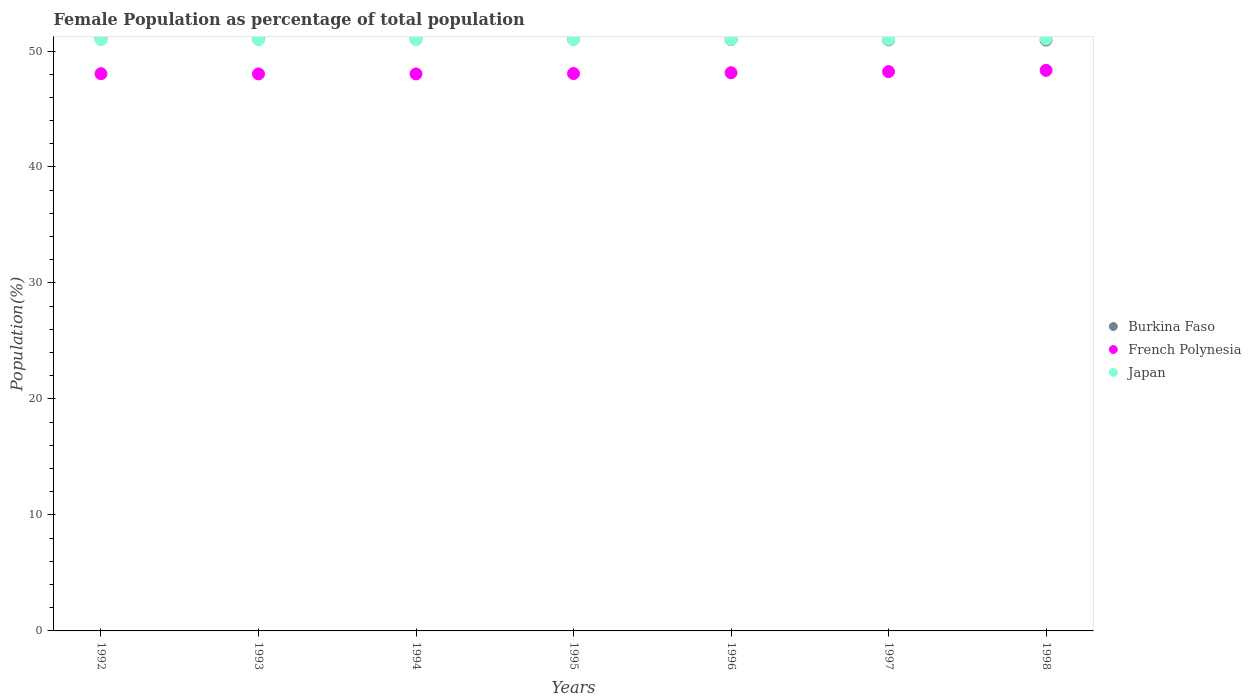What is the female population in in Japan in 1993?
Offer a very short reply. 50.98. Across all years, what is the maximum female population in in Burkina Faso?
Keep it short and to the point. 51.09. Across all years, what is the minimum female population in in Japan?
Your answer should be compact. 50.98. In which year was the female population in in French Polynesia minimum?
Give a very brief answer. 1994. What is the total female population in in French Polynesia in the graph?
Ensure brevity in your answer.  336.83. What is the difference between the female population in in French Polynesia in 1993 and that in 1998?
Give a very brief answer. -0.31. What is the difference between the female population in in French Polynesia in 1998 and the female population in in Burkina Faso in 1996?
Your response must be concise. -2.66. What is the average female population in in Japan per year?
Your answer should be very brief. 51. In the year 1998, what is the difference between the female population in in French Polynesia and female population in in Burkina Faso?
Keep it short and to the point. -2.61. What is the ratio of the female population in in Burkina Faso in 1992 to that in 1994?
Ensure brevity in your answer.  1. Is the female population in in French Polynesia in 1993 less than that in 1995?
Your answer should be very brief. Yes. What is the difference between the highest and the second highest female population in in Burkina Faso?
Your answer should be very brief. 0.03. What is the difference between the highest and the lowest female population in in Burkina Faso?
Ensure brevity in your answer.  0.15. In how many years, is the female population in in French Polynesia greater than the average female population in in French Polynesia taken over all years?
Keep it short and to the point. 3. Is it the case that in every year, the sum of the female population in in Burkina Faso and female population in in Japan  is greater than the female population in in French Polynesia?
Ensure brevity in your answer.  Yes. Is the female population in in Japan strictly greater than the female population in in French Polynesia over the years?
Keep it short and to the point. Yes. How many years are there in the graph?
Your response must be concise. 7. What is the difference between two consecutive major ticks on the Y-axis?
Keep it short and to the point. 10. Where does the legend appear in the graph?
Your response must be concise. Center right. How are the legend labels stacked?
Ensure brevity in your answer.  Vertical. What is the title of the graph?
Keep it short and to the point. Female Population as percentage of total population. What is the label or title of the X-axis?
Make the answer very short. Years. What is the label or title of the Y-axis?
Keep it short and to the point. Population(%). What is the Population(%) of Burkina Faso in 1992?
Your answer should be very brief. 51.09. What is the Population(%) in French Polynesia in 1992?
Keep it short and to the point. 48.05. What is the Population(%) in Japan in 1992?
Keep it short and to the point. 50.98. What is the Population(%) in Burkina Faso in 1993?
Offer a terse response. 51.07. What is the Population(%) of French Polynesia in 1993?
Provide a succinct answer. 48.03. What is the Population(%) in Japan in 1993?
Offer a very short reply. 50.98. What is the Population(%) in Burkina Faso in 1994?
Make the answer very short. 51.04. What is the Population(%) of French Polynesia in 1994?
Your answer should be compact. 48.02. What is the Population(%) in Japan in 1994?
Provide a short and direct response. 50.98. What is the Population(%) of Burkina Faso in 1995?
Your answer should be compact. 51.01. What is the Population(%) in French Polynesia in 1995?
Your response must be concise. 48.06. What is the Population(%) of Japan in 1995?
Provide a short and direct response. 50.99. What is the Population(%) in Burkina Faso in 1996?
Your answer should be very brief. 50.99. What is the Population(%) of French Polynesia in 1996?
Offer a very short reply. 48.13. What is the Population(%) in Japan in 1996?
Keep it short and to the point. 51. What is the Population(%) of Burkina Faso in 1997?
Your response must be concise. 50.97. What is the Population(%) in French Polynesia in 1997?
Offer a very short reply. 48.22. What is the Population(%) of Japan in 1997?
Give a very brief answer. 51.02. What is the Population(%) of Burkina Faso in 1998?
Ensure brevity in your answer.  50.94. What is the Population(%) in French Polynesia in 1998?
Provide a succinct answer. 48.33. What is the Population(%) in Japan in 1998?
Provide a short and direct response. 51.04. Across all years, what is the maximum Population(%) of Burkina Faso?
Ensure brevity in your answer.  51.09. Across all years, what is the maximum Population(%) in French Polynesia?
Give a very brief answer. 48.33. Across all years, what is the maximum Population(%) of Japan?
Give a very brief answer. 51.04. Across all years, what is the minimum Population(%) in Burkina Faso?
Provide a short and direct response. 50.94. Across all years, what is the minimum Population(%) of French Polynesia?
Provide a succinct answer. 48.02. Across all years, what is the minimum Population(%) of Japan?
Ensure brevity in your answer.  50.98. What is the total Population(%) in Burkina Faso in the graph?
Offer a very short reply. 357.11. What is the total Population(%) in French Polynesia in the graph?
Provide a succinct answer. 336.83. What is the total Population(%) of Japan in the graph?
Provide a succinct answer. 356.99. What is the difference between the Population(%) in Burkina Faso in 1992 and that in 1993?
Your answer should be very brief. 0.03. What is the difference between the Population(%) in French Polynesia in 1992 and that in 1993?
Give a very brief answer. 0.02. What is the difference between the Population(%) in Japan in 1992 and that in 1993?
Make the answer very short. -0. What is the difference between the Population(%) of Burkina Faso in 1992 and that in 1994?
Give a very brief answer. 0.05. What is the difference between the Population(%) of French Polynesia in 1992 and that in 1994?
Ensure brevity in your answer.  0.02. What is the difference between the Population(%) of Japan in 1992 and that in 1994?
Your answer should be very brief. -0. What is the difference between the Population(%) of Burkina Faso in 1992 and that in 1995?
Your answer should be compact. 0.08. What is the difference between the Population(%) of French Polynesia in 1992 and that in 1995?
Provide a short and direct response. -0.01. What is the difference between the Population(%) of Japan in 1992 and that in 1995?
Ensure brevity in your answer.  -0.01. What is the difference between the Population(%) in Burkina Faso in 1992 and that in 1996?
Your answer should be very brief. 0.1. What is the difference between the Population(%) in French Polynesia in 1992 and that in 1996?
Your response must be concise. -0.08. What is the difference between the Population(%) in Japan in 1992 and that in 1996?
Your answer should be very brief. -0.02. What is the difference between the Population(%) in Burkina Faso in 1992 and that in 1997?
Your response must be concise. 0.12. What is the difference between the Population(%) of French Polynesia in 1992 and that in 1997?
Give a very brief answer. -0.18. What is the difference between the Population(%) in Japan in 1992 and that in 1997?
Your answer should be very brief. -0.04. What is the difference between the Population(%) of Burkina Faso in 1992 and that in 1998?
Make the answer very short. 0.15. What is the difference between the Population(%) in French Polynesia in 1992 and that in 1998?
Provide a short and direct response. -0.29. What is the difference between the Population(%) of Japan in 1992 and that in 1998?
Ensure brevity in your answer.  -0.06. What is the difference between the Population(%) in Burkina Faso in 1993 and that in 1994?
Your answer should be very brief. 0.03. What is the difference between the Population(%) of French Polynesia in 1993 and that in 1994?
Your response must be concise. 0. What is the difference between the Population(%) of Japan in 1993 and that in 1994?
Offer a terse response. -0. What is the difference between the Population(%) in Burkina Faso in 1993 and that in 1995?
Keep it short and to the point. 0.05. What is the difference between the Population(%) in French Polynesia in 1993 and that in 1995?
Keep it short and to the point. -0.03. What is the difference between the Population(%) in Japan in 1993 and that in 1995?
Offer a very short reply. -0.01. What is the difference between the Population(%) in Burkina Faso in 1993 and that in 1996?
Your response must be concise. 0.08. What is the difference between the Population(%) of French Polynesia in 1993 and that in 1996?
Your answer should be compact. -0.1. What is the difference between the Population(%) of Japan in 1993 and that in 1996?
Your answer should be very brief. -0.02. What is the difference between the Population(%) in Burkina Faso in 1993 and that in 1997?
Your answer should be very brief. 0.1. What is the difference between the Population(%) of French Polynesia in 1993 and that in 1997?
Offer a very short reply. -0.2. What is the difference between the Population(%) of Japan in 1993 and that in 1997?
Your response must be concise. -0.04. What is the difference between the Population(%) of Burkina Faso in 1993 and that in 1998?
Ensure brevity in your answer.  0.12. What is the difference between the Population(%) in French Polynesia in 1993 and that in 1998?
Offer a terse response. -0.31. What is the difference between the Population(%) in Japan in 1993 and that in 1998?
Give a very brief answer. -0.06. What is the difference between the Population(%) in Burkina Faso in 1994 and that in 1995?
Your answer should be very brief. 0.03. What is the difference between the Population(%) in French Polynesia in 1994 and that in 1995?
Your answer should be compact. -0.03. What is the difference between the Population(%) in Japan in 1994 and that in 1995?
Your answer should be very brief. -0.01. What is the difference between the Population(%) in Burkina Faso in 1994 and that in 1996?
Your answer should be compact. 0.05. What is the difference between the Population(%) in French Polynesia in 1994 and that in 1996?
Give a very brief answer. -0.1. What is the difference between the Population(%) in Japan in 1994 and that in 1996?
Your response must be concise. -0.02. What is the difference between the Population(%) of Burkina Faso in 1994 and that in 1997?
Offer a terse response. 0.07. What is the difference between the Population(%) of French Polynesia in 1994 and that in 1997?
Provide a short and direct response. -0.2. What is the difference between the Population(%) of Japan in 1994 and that in 1997?
Keep it short and to the point. -0.04. What is the difference between the Population(%) of Burkina Faso in 1994 and that in 1998?
Make the answer very short. 0.1. What is the difference between the Population(%) in French Polynesia in 1994 and that in 1998?
Make the answer very short. -0.31. What is the difference between the Population(%) in Japan in 1994 and that in 1998?
Your answer should be very brief. -0.06. What is the difference between the Population(%) of Burkina Faso in 1995 and that in 1996?
Provide a succinct answer. 0.02. What is the difference between the Population(%) in French Polynesia in 1995 and that in 1996?
Give a very brief answer. -0.07. What is the difference between the Population(%) in Japan in 1995 and that in 1996?
Your answer should be compact. -0.01. What is the difference between the Population(%) of Burkina Faso in 1995 and that in 1997?
Your response must be concise. 0.05. What is the difference between the Population(%) in French Polynesia in 1995 and that in 1997?
Your answer should be very brief. -0.17. What is the difference between the Population(%) in Japan in 1995 and that in 1997?
Provide a succinct answer. -0.03. What is the difference between the Population(%) in Burkina Faso in 1995 and that in 1998?
Ensure brevity in your answer.  0.07. What is the difference between the Population(%) in French Polynesia in 1995 and that in 1998?
Ensure brevity in your answer.  -0.28. What is the difference between the Population(%) in Japan in 1995 and that in 1998?
Offer a very short reply. -0.05. What is the difference between the Population(%) of Burkina Faso in 1996 and that in 1997?
Offer a very short reply. 0.02. What is the difference between the Population(%) in French Polynesia in 1996 and that in 1997?
Offer a terse response. -0.1. What is the difference between the Population(%) of Japan in 1996 and that in 1997?
Ensure brevity in your answer.  -0.02. What is the difference between the Population(%) in Burkina Faso in 1996 and that in 1998?
Your response must be concise. 0.05. What is the difference between the Population(%) of French Polynesia in 1996 and that in 1998?
Provide a succinct answer. -0.21. What is the difference between the Population(%) of Japan in 1996 and that in 1998?
Give a very brief answer. -0.04. What is the difference between the Population(%) in Burkina Faso in 1997 and that in 1998?
Your answer should be compact. 0.02. What is the difference between the Population(%) in French Polynesia in 1997 and that in 1998?
Your answer should be compact. -0.11. What is the difference between the Population(%) in Japan in 1997 and that in 1998?
Make the answer very short. -0.02. What is the difference between the Population(%) of Burkina Faso in 1992 and the Population(%) of French Polynesia in 1993?
Your response must be concise. 3.07. What is the difference between the Population(%) in Burkina Faso in 1992 and the Population(%) in Japan in 1993?
Make the answer very short. 0.11. What is the difference between the Population(%) of French Polynesia in 1992 and the Population(%) of Japan in 1993?
Your answer should be compact. -2.93. What is the difference between the Population(%) of Burkina Faso in 1992 and the Population(%) of French Polynesia in 1994?
Give a very brief answer. 3.07. What is the difference between the Population(%) of Burkina Faso in 1992 and the Population(%) of Japan in 1994?
Your answer should be very brief. 0.11. What is the difference between the Population(%) in French Polynesia in 1992 and the Population(%) in Japan in 1994?
Your response must be concise. -2.94. What is the difference between the Population(%) of Burkina Faso in 1992 and the Population(%) of French Polynesia in 1995?
Your response must be concise. 3.04. What is the difference between the Population(%) in Burkina Faso in 1992 and the Population(%) in Japan in 1995?
Your answer should be compact. 0.1. What is the difference between the Population(%) of French Polynesia in 1992 and the Population(%) of Japan in 1995?
Make the answer very short. -2.94. What is the difference between the Population(%) of Burkina Faso in 1992 and the Population(%) of French Polynesia in 1996?
Give a very brief answer. 2.97. What is the difference between the Population(%) in Burkina Faso in 1992 and the Population(%) in Japan in 1996?
Give a very brief answer. 0.09. What is the difference between the Population(%) in French Polynesia in 1992 and the Population(%) in Japan in 1996?
Keep it short and to the point. -2.96. What is the difference between the Population(%) of Burkina Faso in 1992 and the Population(%) of French Polynesia in 1997?
Offer a terse response. 2.87. What is the difference between the Population(%) of Burkina Faso in 1992 and the Population(%) of Japan in 1997?
Your response must be concise. 0.07. What is the difference between the Population(%) of French Polynesia in 1992 and the Population(%) of Japan in 1997?
Ensure brevity in your answer.  -2.97. What is the difference between the Population(%) in Burkina Faso in 1992 and the Population(%) in French Polynesia in 1998?
Provide a short and direct response. 2.76. What is the difference between the Population(%) of Burkina Faso in 1992 and the Population(%) of Japan in 1998?
Your answer should be compact. 0.05. What is the difference between the Population(%) in French Polynesia in 1992 and the Population(%) in Japan in 1998?
Your answer should be compact. -3. What is the difference between the Population(%) of Burkina Faso in 1993 and the Population(%) of French Polynesia in 1994?
Give a very brief answer. 3.04. What is the difference between the Population(%) in Burkina Faso in 1993 and the Population(%) in Japan in 1994?
Provide a short and direct response. 0.08. What is the difference between the Population(%) in French Polynesia in 1993 and the Population(%) in Japan in 1994?
Keep it short and to the point. -2.96. What is the difference between the Population(%) of Burkina Faso in 1993 and the Population(%) of French Polynesia in 1995?
Provide a succinct answer. 3.01. What is the difference between the Population(%) of Burkina Faso in 1993 and the Population(%) of Japan in 1995?
Make the answer very short. 0.08. What is the difference between the Population(%) of French Polynesia in 1993 and the Population(%) of Japan in 1995?
Give a very brief answer. -2.96. What is the difference between the Population(%) in Burkina Faso in 1993 and the Population(%) in French Polynesia in 1996?
Your answer should be very brief. 2.94. What is the difference between the Population(%) in Burkina Faso in 1993 and the Population(%) in Japan in 1996?
Provide a short and direct response. 0.06. What is the difference between the Population(%) of French Polynesia in 1993 and the Population(%) of Japan in 1996?
Your answer should be compact. -2.98. What is the difference between the Population(%) in Burkina Faso in 1993 and the Population(%) in French Polynesia in 1997?
Provide a succinct answer. 2.84. What is the difference between the Population(%) in Burkina Faso in 1993 and the Population(%) in Japan in 1997?
Your response must be concise. 0.05. What is the difference between the Population(%) of French Polynesia in 1993 and the Population(%) of Japan in 1997?
Your response must be concise. -2.99. What is the difference between the Population(%) of Burkina Faso in 1993 and the Population(%) of French Polynesia in 1998?
Offer a terse response. 2.73. What is the difference between the Population(%) of Burkina Faso in 1993 and the Population(%) of Japan in 1998?
Offer a very short reply. 0.02. What is the difference between the Population(%) in French Polynesia in 1993 and the Population(%) in Japan in 1998?
Make the answer very short. -3.01. What is the difference between the Population(%) in Burkina Faso in 1994 and the Population(%) in French Polynesia in 1995?
Offer a terse response. 2.98. What is the difference between the Population(%) of Burkina Faso in 1994 and the Population(%) of Japan in 1995?
Your answer should be compact. 0.05. What is the difference between the Population(%) in French Polynesia in 1994 and the Population(%) in Japan in 1995?
Provide a short and direct response. -2.97. What is the difference between the Population(%) of Burkina Faso in 1994 and the Population(%) of French Polynesia in 1996?
Keep it short and to the point. 2.91. What is the difference between the Population(%) in Burkina Faso in 1994 and the Population(%) in Japan in 1996?
Your answer should be compact. 0.04. What is the difference between the Population(%) of French Polynesia in 1994 and the Population(%) of Japan in 1996?
Your answer should be compact. -2.98. What is the difference between the Population(%) of Burkina Faso in 1994 and the Population(%) of French Polynesia in 1997?
Offer a very short reply. 2.82. What is the difference between the Population(%) of Burkina Faso in 1994 and the Population(%) of Japan in 1997?
Your answer should be very brief. 0.02. What is the difference between the Population(%) in French Polynesia in 1994 and the Population(%) in Japan in 1997?
Ensure brevity in your answer.  -3. What is the difference between the Population(%) in Burkina Faso in 1994 and the Population(%) in French Polynesia in 1998?
Your response must be concise. 2.71. What is the difference between the Population(%) of Burkina Faso in 1994 and the Population(%) of Japan in 1998?
Keep it short and to the point. -0. What is the difference between the Population(%) of French Polynesia in 1994 and the Population(%) of Japan in 1998?
Offer a very short reply. -3.02. What is the difference between the Population(%) of Burkina Faso in 1995 and the Population(%) of French Polynesia in 1996?
Ensure brevity in your answer.  2.89. What is the difference between the Population(%) in Burkina Faso in 1995 and the Population(%) in Japan in 1996?
Provide a succinct answer. 0.01. What is the difference between the Population(%) of French Polynesia in 1995 and the Population(%) of Japan in 1996?
Keep it short and to the point. -2.95. What is the difference between the Population(%) of Burkina Faso in 1995 and the Population(%) of French Polynesia in 1997?
Your answer should be very brief. 2.79. What is the difference between the Population(%) in Burkina Faso in 1995 and the Population(%) in Japan in 1997?
Your response must be concise. -0.01. What is the difference between the Population(%) of French Polynesia in 1995 and the Population(%) of Japan in 1997?
Make the answer very short. -2.96. What is the difference between the Population(%) of Burkina Faso in 1995 and the Population(%) of French Polynesia in 1998?
Your answer should be very brief. 2.68. What is the difference between the Population(%) of Burkina Faso in 1995 and the Population(%) of Japan in 1998?
Offer a very short reply. -0.03. What is the difference between the Population(%) of French Polynesia in 1995 and the Population(%) of Japan in 1998?
Your response must be concise. -2.98. What is the difference between the Population(%) in Burkina Faso in 1996 and the Population(%) in French Polynesia in 1997?
Your answer should be compact. 2.77. What is the difference between the Population(%) in Burkina Faso in 1996 and the Population(%) in Japan in 1997?
Provide a short and direct response. -0.03. What is the difference between the Population(%) in French Polynesia in 1996 and the Population(%) in Japan in 1997?
Your answer should be very brief. -2.89. What is the difference between the Population(%) in Burkina Faso in 1996 and the Population(%) in French Polynesia in 1998?
Ensure brevity in your answer.  2.66. What is the difference between the Population(%) of Burkina Faso in 1996 and the Population(%) of Japan in 1998?
Offer a very short reply. -0.05. What is the difference between the Population(%) in French Polynesia in 1996 and the Population(%) in Japan in 1998?
Your answer should be very brief. -2.92. What is the difference between the Population(%) of Burkina Faso in 1997 and the Population(%) of French Polynesia in 1998?
Offer a terse response. 2.64. What is the difference between the Population(%) in Burkina Faso in 1997 and the Population(%) in Japan in 1998?
Make the answer very short. -0.07. What is the difference between the Population(%) of French Polynesia in 1997 and the Population(%) of Japan in 1998?
Offer a very short reply. -2.82. What is the average Population(%) in Burkina Faso per year?
Provide a succinct answer. 51.02. What is the average Population(%) of French Polynesia per year?
Keep it short and to the point. 48.12. What is the average Population(%) of Japan per year?
Provide a succinct answer. 51. In the year 1992, what is the difference between the Population(%) of Burkina Faso and Population(%) of French Polynesia?
Offer a very short reply. 3.05. In the year 1992, what is the difference between the Population(%) in Burkina Faso and Population(%) in Japan?
Your answer should be very brief. 0.11. In the year 1992, what is the difference between the Population(%) in French Polynesia and Population(%) in Japan?
Offer a terse response. -2.93. In the year 1993, what is the difference between the Population(%) in Burkina Faso and Population(%) in French Polynesia?
Your answer should be very brief. 3.04. In the year 1993, what is the difference between the Population(%) in Burkina Faso and Population(%) in Japan?
Make the answer very short. 0.09. In the year 1993, what is the difference between the Population(%) in French Polynesia and Population(%) in Japan?
Your answer should be very brief. -2.95. In the year 1994, what is the difference between the Population(%) in Burkina Faso and Population(%) in French Polynesia?
Ensure brevity in your answer.  3.02. In the year 1994, what is the difference between the Population(%) in Burkina Faso and Population(%) in Japan?
Provide a succinct answer. 0.06. In the year 1994, what is the difference between the Population(%) in French Polynesia and Population(%) in Japan?
Ensure brevity in your answer.  -2.96. In the year 1995, what is the difference between the Population(%) of Burkina Faso and Population(%) of French Polynesia?
Offer a very short reply. 2.96. In the year 1995, what is the difference between the Population(%) in Burkina Faso and Population(%) in Japan?
Your response must be concise. 0.02. In the year 1995, what is the difference between the Population(%) of French Polynesia and Population(%) of Japan?
Your answer should be very brief. -2.93. In the year 1996, what is the difference between the Population(%) of Burkina Faso and Population(%) of French Polynesia?
Make the answer very short. 2.87. In the year 1996, what is the difference between the Population(%) of Burkina Faso and Population(%) of Japan?
Ensure brevity in your answer.  -0.01. In the year 1996, what is the difference between the Population(%) of French Polynesia and Population(%) of Japan?
Provide a succinct answer. -2.88. In the year 1997, what is the difference between the Population(%) of Burkina Faso and Population(%) of French Polynesia?
Offer a very short reply. 2.75. In the year 1997, what is the difference between the Population(%) in Burkina Faso and Population(%) in Japan?
Offer a very short reply. -0.05. In the year 1997, what is the difference between the Population(%) in French Polynesia and Population(%) in Japan?
Your response must be concise. -2.8. In the year 1998, what is the difference between the Population(%) of Burkina Faso and Population(%) of French Polynesia?
Provide a short and direct response. 2.61. In the year 1998, what is the difference between the Population(%) of Burkina Faso and Population(%) of Japan?
Give a very brief answer. -0.1. In the year 1998, what is the difference between the Population(%) of French Polynesia and Population(%) of Japan?
Ensure brevity in your answer.  -2.71. What is the ratio of the Population(%) in French Polynesia in 1992 to that in 1993?
Provide a succinct answer. 1. What is the ratio of the Population(%) in French Polynesia in 1992 to that in 1994?
Your response must be concise. 1. What is the ratio of the Population(%) in Burkina Faso in 1992 to that in 1996?
Provide a succinct answer. 1. What is the ratio of the Population(%) in French Polynesia in 1992 to that in 1996?
Provide a succinct answer. 1. What is the ratio of the Population(%) of Japan in 1992 to that in 1996?
Ensure brevity in your answer.  1. What is the ratio of the Population(%) of Burkina Faso in 1992 to that in 1997?
Make the answer very short. 1. What is the ratio of the Population(%) in French Polynesia in 1992 to that in 1997?
Your answer should be very brief. 1. What is the ratio of the Population(%) in French Polynesia in 1993 to that in 1994?
Keep it short and to the point. 1. What is the ratio of the Population(%) of French Polynesia in 1993 to that in 1995?
Give a very brief answer. 1. What is the ratio of the Population(%) in Burkina Faso in 1993 to that in 1996?
Provide a succinct answer. 1. What is the ratio of the Population(%) in Japan in 1993 to that in 1996?
Your answer should be compact. 1. What is the ratio of the Population(%) in Burkina Faso in 1993 to that in 1997?
Keep it short and to the point. 1. What is the ratio of the Population(%) of Japan in 1993 to that in 1997?
Keep it short and to the point. 1. What is the ratio of the Population(%) of French Polynesia in 1993 to that in 1998?
Your response must be concise. 0.99. What is the ratio of the Population(%) of Japan in 1993 to that in 1998?
Make the answer very short. 1. What is the ratio of the Population(%) in Burkina Faso in 1994 to that in 1995?
Ensure brevity in your answer.  1. What is the ratio of the Population(%) of Japan in 1994 to that in 1995?
Provide a succinct answer. 1. What is the ratio of the Population(%) in French Polynesia in 1994 to that in 1997?
Your answer should be very brief. 1. What is the ratio of the Population(%) of Japan in 1994 to that in 1997?
Keep it short and to the point. 1. What is the ratio of the Population(%) of Japan in 1994 to that in 1998?
Give a very brief answer. 1. What is the ratio of the Population(%) in French Polynesia in 1995 to that in 1997?
Your answer should be compact. 1. What is the ratio of the Population(%) in Japan in 1995 to that in 1997?
Provide a succinct answer. 1. What is the ratio of the Population(%) in Burkina Faso in 1995 to that in 1998?
Make the answer very short. 1. What is the ratio of the Population(%) in Burkina Faso in 1996 to that in 1998?
Keep it short and to the point. 1. What is the ratio of the Population(%) in French Polynesia in 1996 to that in 1998?
Your answer should be very brief. 1. What is the ratio of the Population(%) in Japan in 1996 to that in 1998?
Your answer should be very brief. 1. What is the difference between the highest and the second highest Population(%) in Burkina Faso?
Make the answer very short. 0.03. What is the difference between the highest and the second highest Population(%) in French Polynesia?
Provide a succinct answer. 0.11. What is the difference between the highest and the second highest Population(%) of Japan?
Your answer should be very brief. 0.02. What is the difference between the highest and the lowest Population(%) in Burkina Faso?
Ensure brevity in your answer.  0.15. What is the difference between the highest and the lowest Population(%) in French Polynesia?
Keep it short and to the point. 0.31. What is the difference between the highest and the lowest Population(%) of Japan?
Offer a terse response. 0.06. 